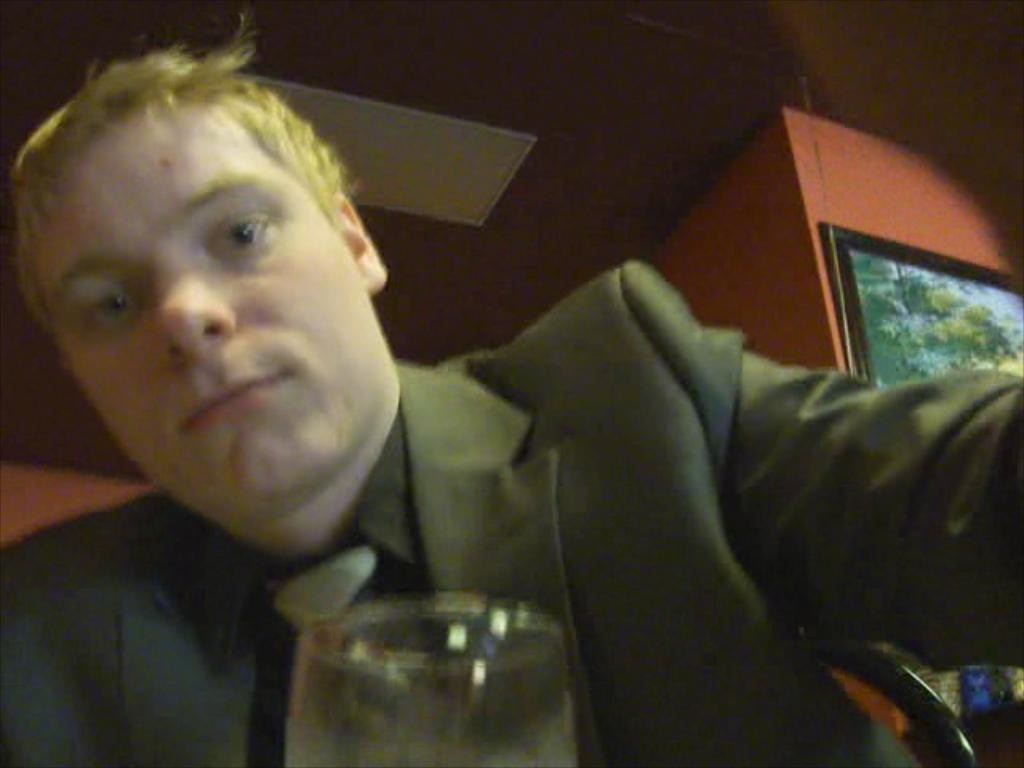Who or what is present in the image? There is a person in the image. What object can be seen near the person? There is a glass in the image. What can be seen in the background of the image? There is a wall in the background of the image. What is on the wall in the background? There is a picture on the wall in the background. What type of straw is being used to support the person in the image? There is no straw present in the image, and the person is not being supported by any object. 